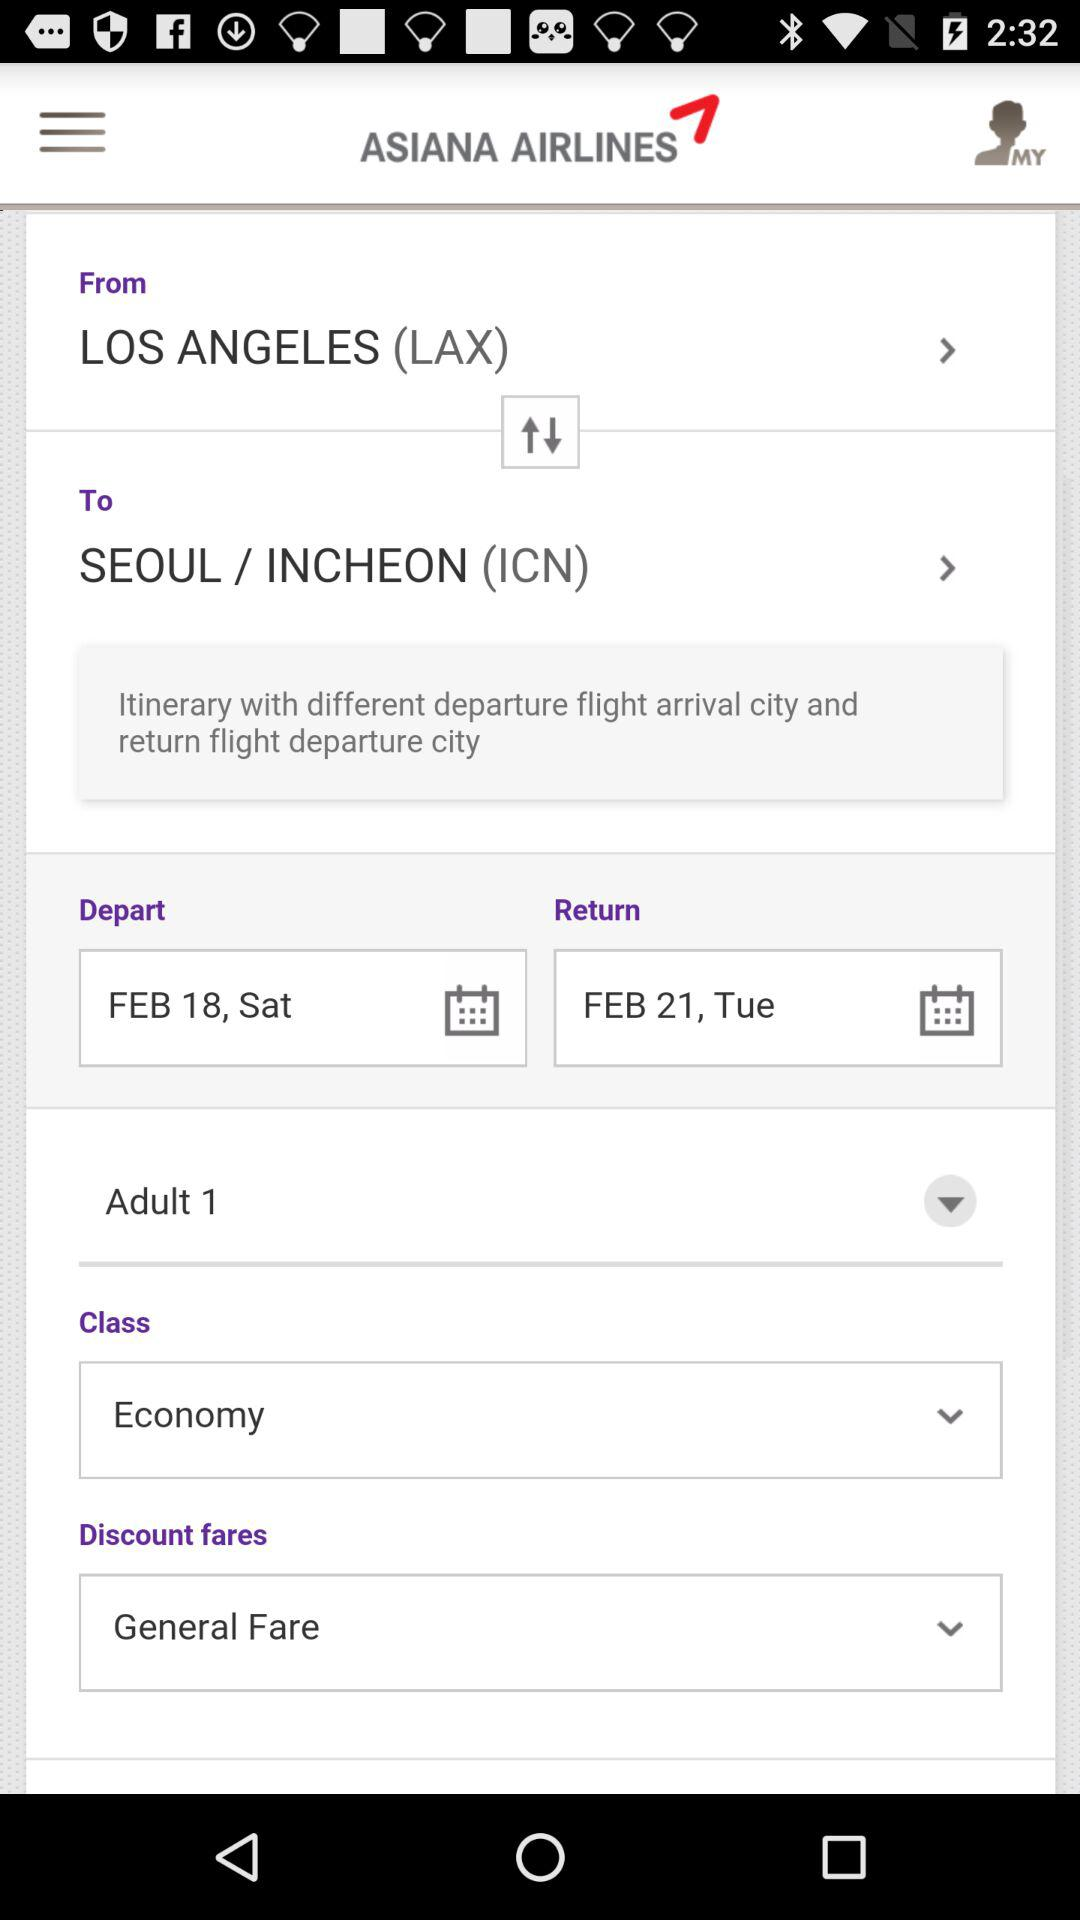What is the arrival city? The arrival city is "SEOUL / INCHEON (ICN)". 